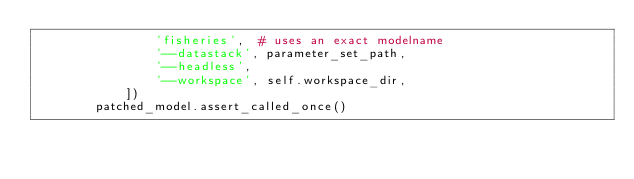Convert code to text. <code><loc_0><loc_0><loc_500><loc_500><_Python_>                'fisheries',  # uses an exact modelname
                '--datastack', parameter_set_path,
                '--headless',
                '--workspace', self.workspace_dir,
            ])
        patched_model.assert_called_once()
</code> 